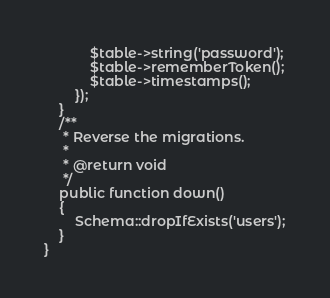Convert code to text. <code><loc_0><loc_0><loc_500><loc_500><_PHP_>            $table->string('password');
            $table->rememberToken();
            $table->timestamps();
        });
    }
    /**
     * Reverse the migrations.
     *
     * @return void
     */
    public function down()
    {
        Schema::dropIfExists('users');
    }
}
</code> 